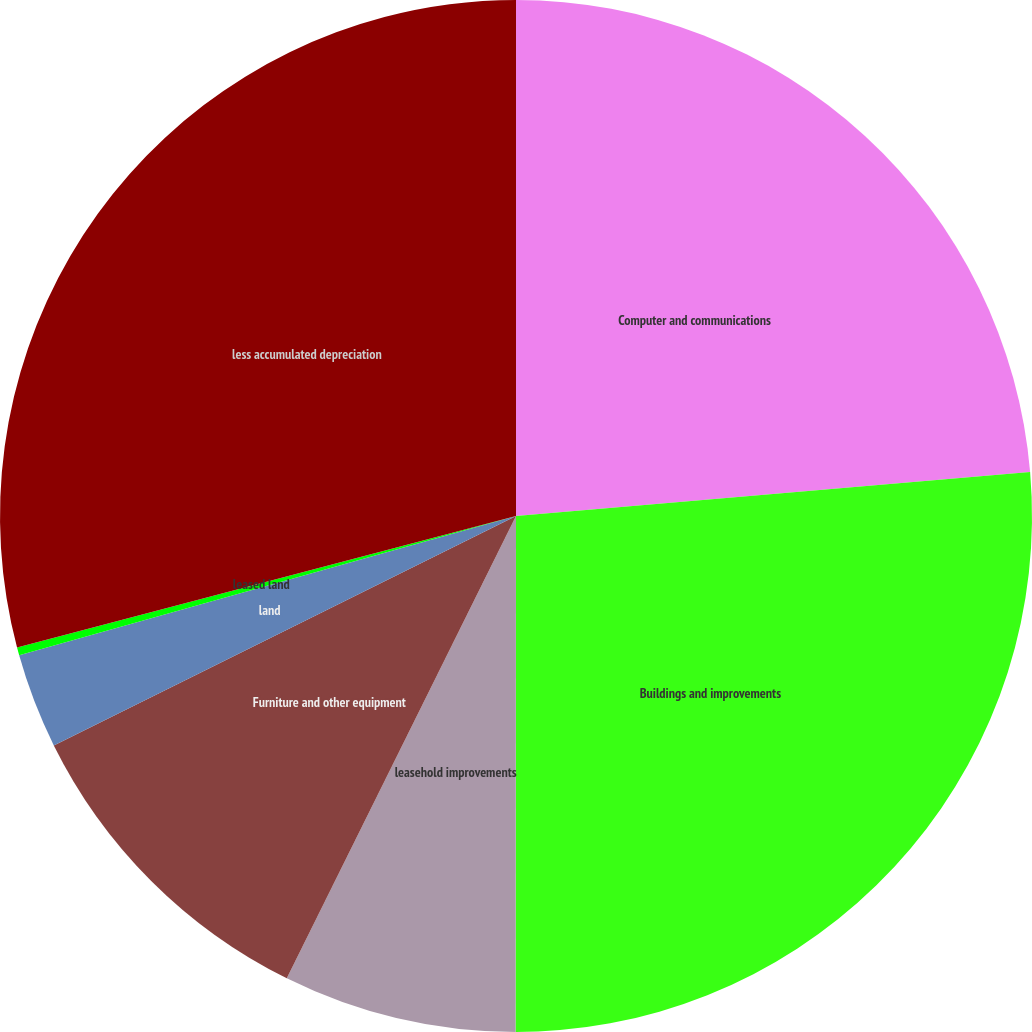<chart> <loc_0><loc_0><loc_500><loc_500><pie_chart><fcel>Computer and communications<fcel>Buildings and improvements<fcel>leasehold improvements<fcel>Furniture and other equipment<fcel>land<fcel>leased land<fcel>less accumulated depreciation<nl><fcel>23.64%<fcel>26.37%<fcel>7.31%<fcel>10.34%<fcel>2.98%<fcel>0.25%<fcel>29.1%<nl></chart> 